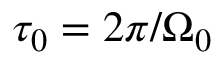<formula> <loc_0><loc_0><loc_500><loc_500>\tau _ { 0 } = 2 \pi / \Omega _ { 0 }</formula> 